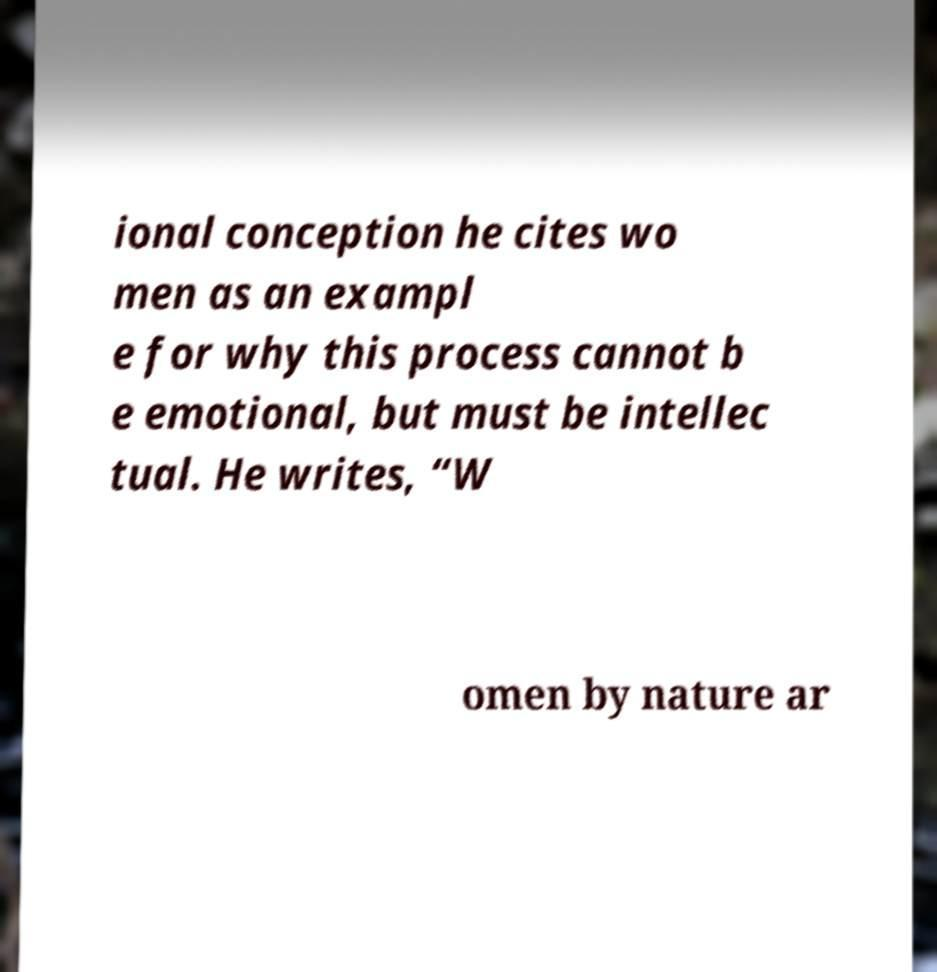Please identify and transcribe the text found in this image. ional conception he cites wo men as an exampl e for why this process cannot b e emotional, but must be intellec tual. He writes, “W omen by nature ar 